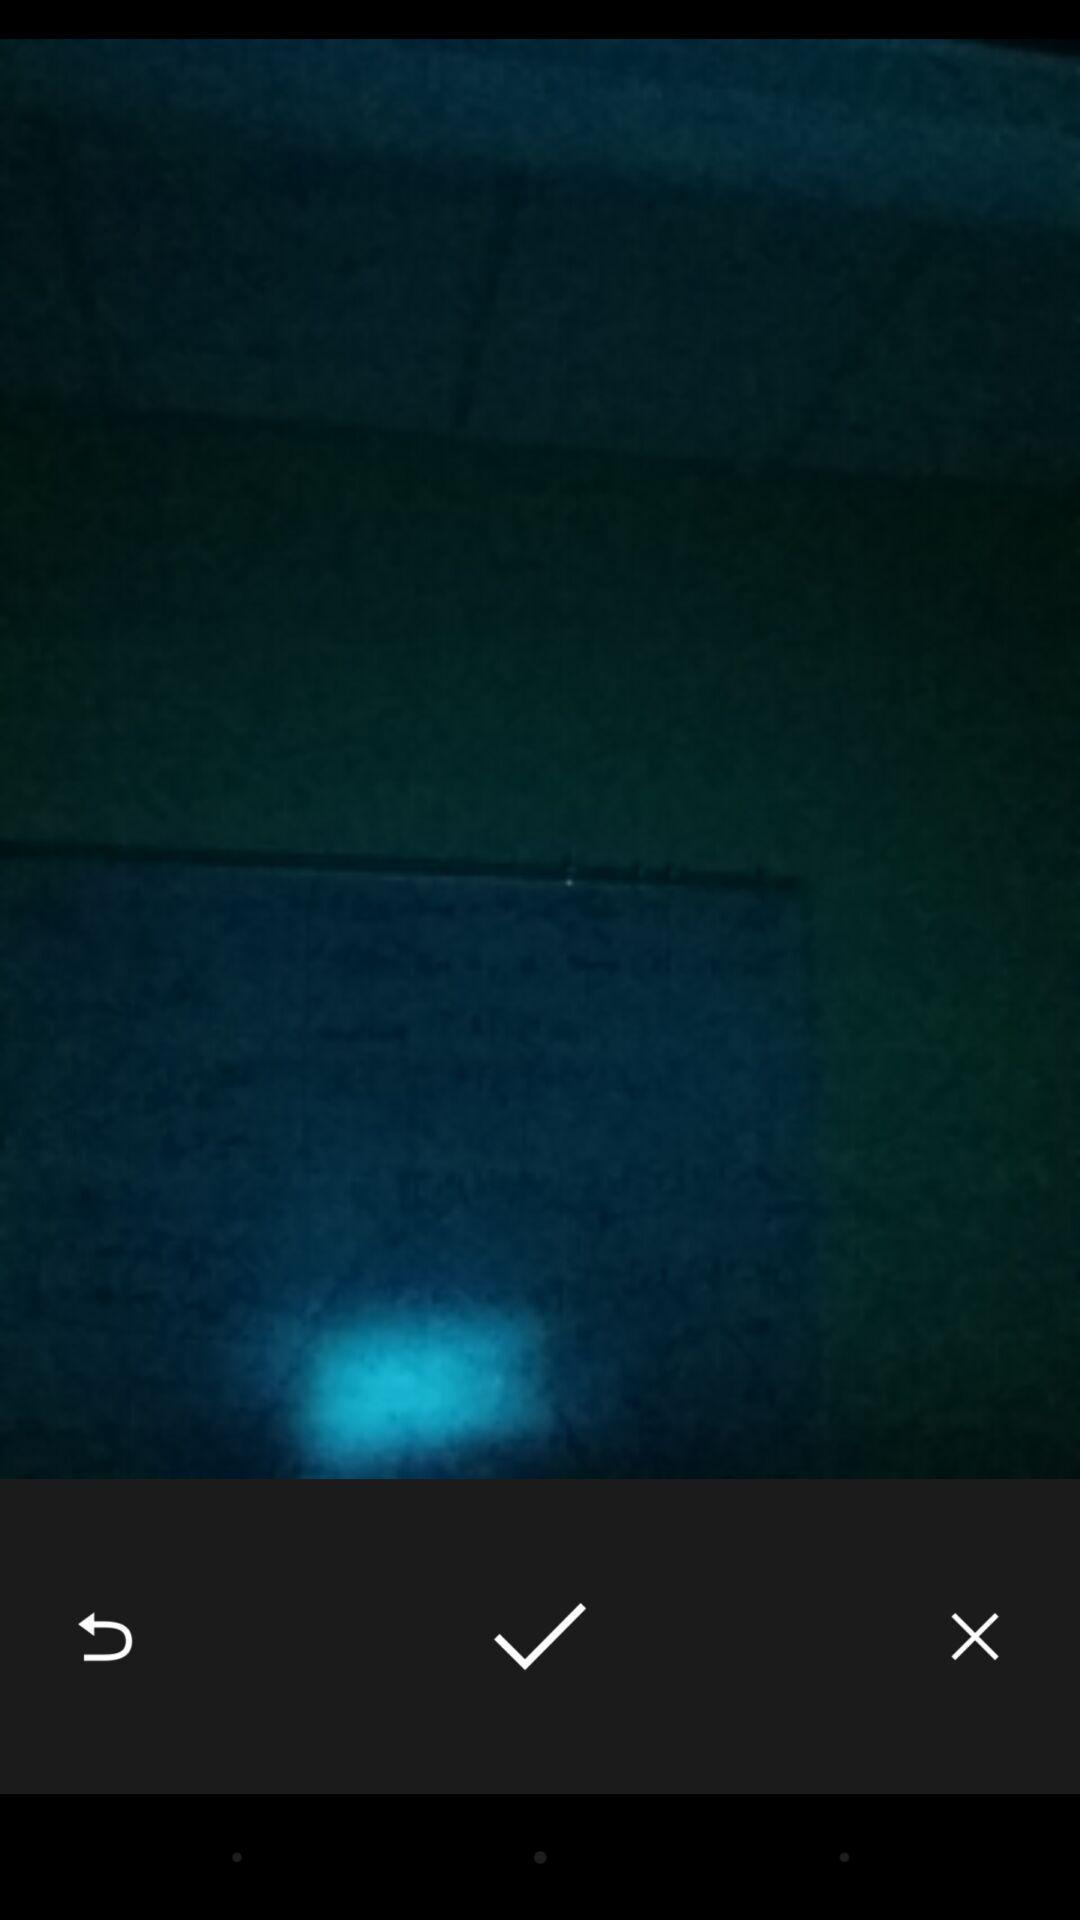Describe the key features of this screenshot. Screen showing various icons like save. 